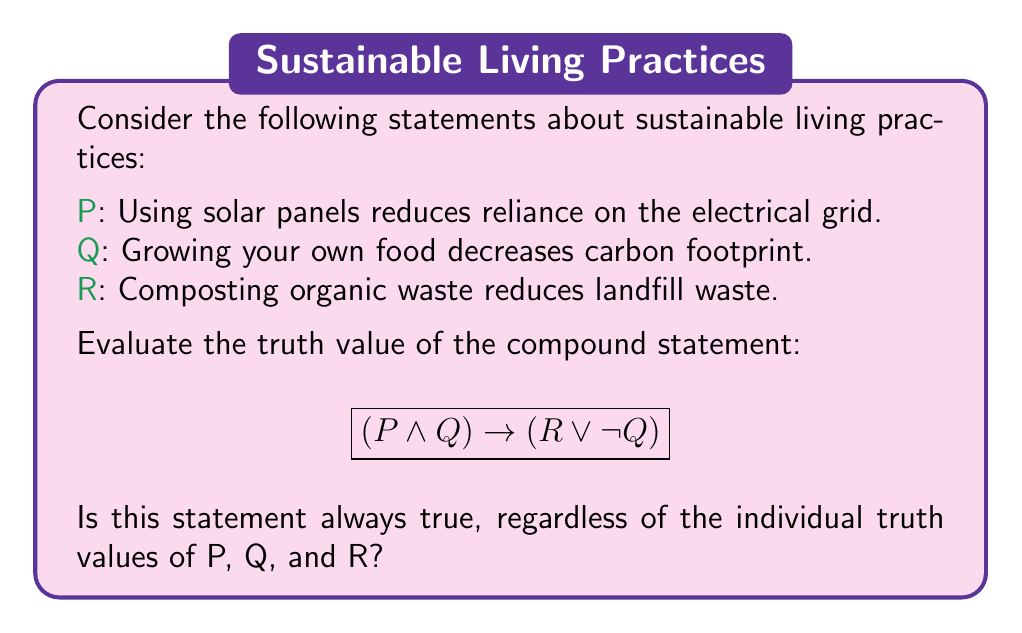Can you solve this math problem? To evaluate the truth value of the compound statement, we need to consider all possible combinations of truth values for P, Q, and R. Let's approach this step-by-step:

1. The statement has the form $(A \rightarrow B)$, where $A = (P \land Q)$ and $B = (R \lor \neg Q)$.

2. Recall that an implication $A \rightarrow B$ is false only when A is true and B is false. It's true in all other cases.

3. Let's consider all possible combinations:

   | P | Q | R | $(P \land Q)$ | $(R \lor \neg Q)$ | $(P \land Q) \rightarrow (R \lor \neg Q)$ |
   |---|---|---|----------------|-------------------|------------------------------------------|
   | T | T | T |       T        |         T         |                   T                      |
   | T | T | F |       T        |         F         |                   F                      |
   | T | F | T |       F        |         T         |                   T                      |
   | T | F | F |       F        |         T         |                   T                      |
   | F | T | T |       F        |         T         |                   T                      |
   | F | T | F |       F        |         F         |                   T                      |
   | F | F | T |       F        |         T         |                   T                      |
   | F | F | F |       F        |         T         |                   T                      |

4. We can see that the compound statement is false only when P and Q are both true, and R is false.

5. In all other cases, the statement is true, either because $(P \land Q)$ is false (making the implication trivially true) or because $(R \lor \neg Q)$ is true.

6. Since there exists a combination of truth values that makes the compound statement false, we can conclude that this statement is not always true.
Answer: False. The compound statement $(P \land Q) \rightarrow (R \lor \neg Q)$ is not always true. It is false when P and Q are both true, and R is false. 